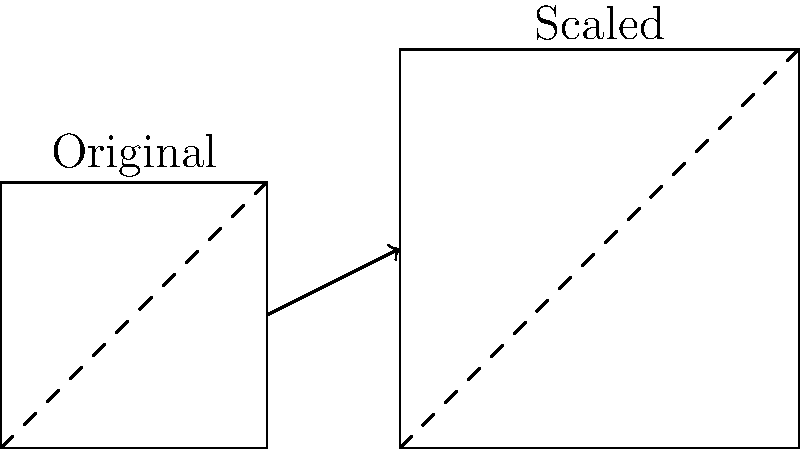As a competing business consultant, I noticed your current business chart doesn't adequately represent your projected expansion. Let's consider a more ambitious scaling approach. If we were to scale your original 100x100 unit chart by a factor of 1.5 in both dimensions, what would be the area of the new chart in square units? How does this compare to your current projection, and what implications might this have for your growth strategy? Let's break this down step-by-step:

1) The original chart is 100x100 units, so its area is:
   $A_{original} = 100 \times 100 = 10,000$ square units

2) The scaling factor is 1.5 in both dimensions. This means:
   New width = $100 \times 1.5 = 150$ units
   New height = $100 \times 1.5 = 150$ units

3) The area of the new chart is:
   $A_{new} = 150 \times 150 = 22,500$ square units

4) To compare, we can calculate the percentage increase:
   Percentage increase = $\frac{A_{new} - A_{original}}{A_{original}} \times 100\%$
                       = $\frac{22,500 - 10,000}{10,000} \times 100\%$
                       = $125\%$

5) Implications for growth strategy:
   - This represents a 125% increase in area, suggesting a much more aggressive growth projection.
   - It implies more than doubling the current business size, which could require significant changes in operations, resources, and market approach.
   - This scaling might be more reflective of exponential growth rather than linear growth, potentially aligning better with ambitious startup or tech company projections.
Answer: 22,500 square units; 125% larger than original 